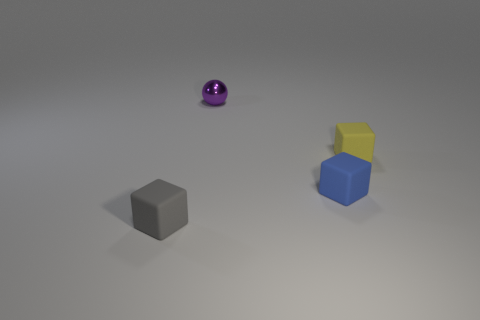Subtract all blue blocks. How many blocks are left? 2 Subtract 1 blocks. How many blocks are left? 2 Add 3 tiny purple shiny balls. How many objects exist? 7 Subtract all spheres. How many objects are left? 3 Subtract all tiny rubber blocks. Subtract all gray cubes. How many objects are left? 0 Add 1 purple things. How many purple things are left? 2 Add 2 cubes. How many cubes exist? 5 Subtract 0 gray balls. How many objects are left? 4 